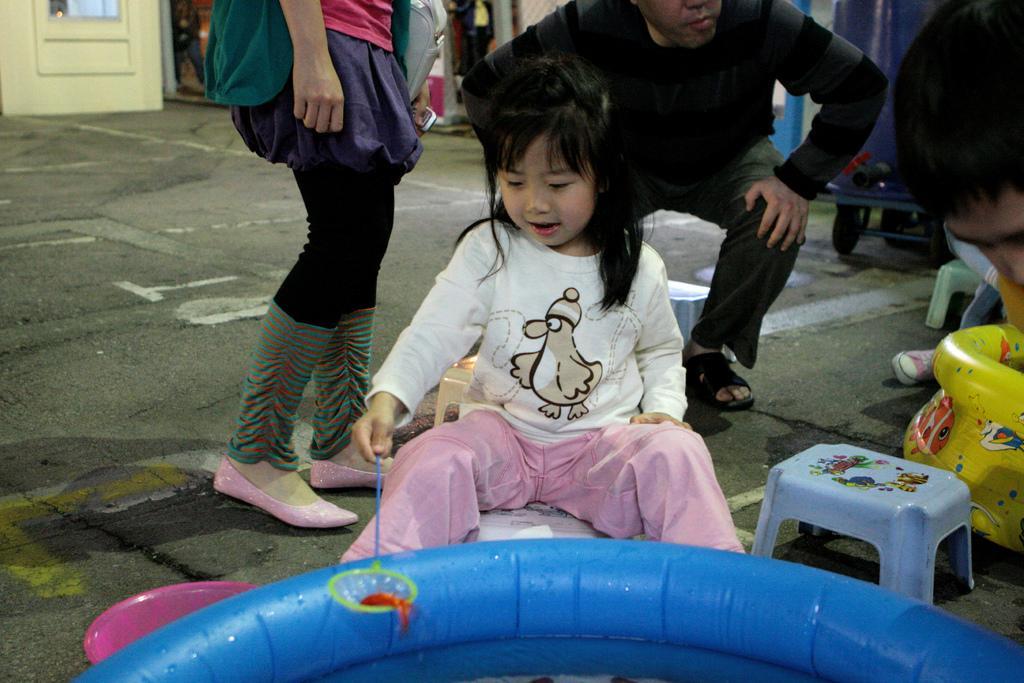Describe this image in one or two sentences. This image is taken outdoors. At the bottom of the image there is a tube with water. In the background there is a door. On the right side of the image there is a person and there is another tub. A kid is sitting on the stool and there is an empty stool on the road. In the middle of the image a kid is sitting on the stool and she is holding an object in her hand. A girl is standing and a man is in a squatting position. 